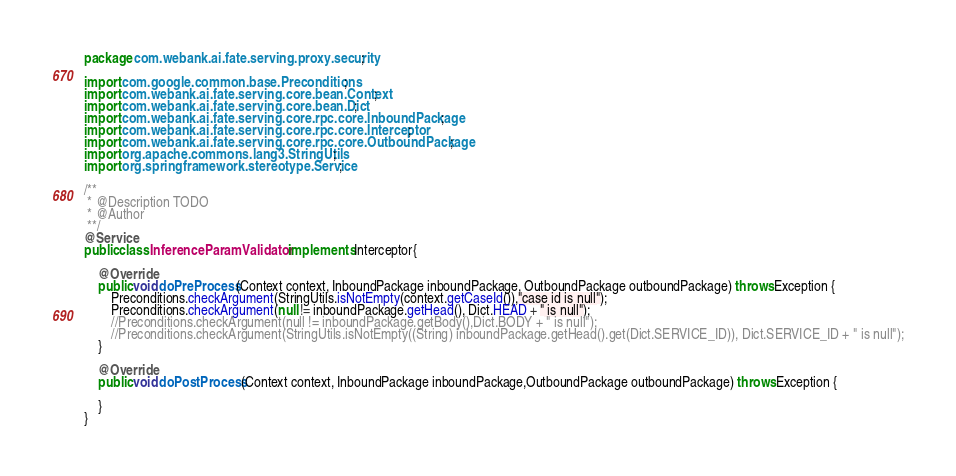Convert code to text. <code><loc_0><loc_0><loc_500><loc_500><_Java_>package com.webank.ai.fate.serving.proxy.security;

import com.google.common.base.Preconditions;
import com.webank.ai.fate.serving.core.bean.Context;
import com.webank.ai.fate.serving.core.bean.Dict;
import com.webank.ai.fate.serving.core.rpc.core.InboundPackage;
import com.webank.ai.fate.serving.core.rpc.core.Interceptor;
import com.webank.ai.fate.serving.core.rpc.core.OutboundPackage;
import org.apache.commons.lang3.StringUtils;
import org.springframework.stereotype.Service;

/**
 * @Description TODO
 * @Author
 **/
@Service
public class InferenceParamValidator implements Interceptor{

    @Override
    public void doPreProcess(Context context, InboundPackage inboundPackage, OutboundPackage outboundPackage) throws Exception {
        Preconditions.checkArgument(StringUtils.isNotEmpty(context.getCaseId()),"case id is null");
        Preconditions.checkArgument(null != inboundPackage.getHead(), Dict.HEAD + " is null");
        //Preconditions.checkArgument(null != inboundPackage.getBody(),Dict.BODY + " is null");
        //Preconditions.checkArgument(StringUtils.isNotEmpty((String) inboundPackage.getHead().get(Dict.SERVICE_ID)), Dict.SERVICE_ID + " is null");
    }

    @Override
    public void doPostProcess(Context context, InboundPackage inboundPackage,OutboundPackage outboundPackage) throws Exception {

    }
}
</code> 